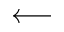<formula> <loc_0><loc_0><loc_500><loc_500>\longleftarrow</formula> 